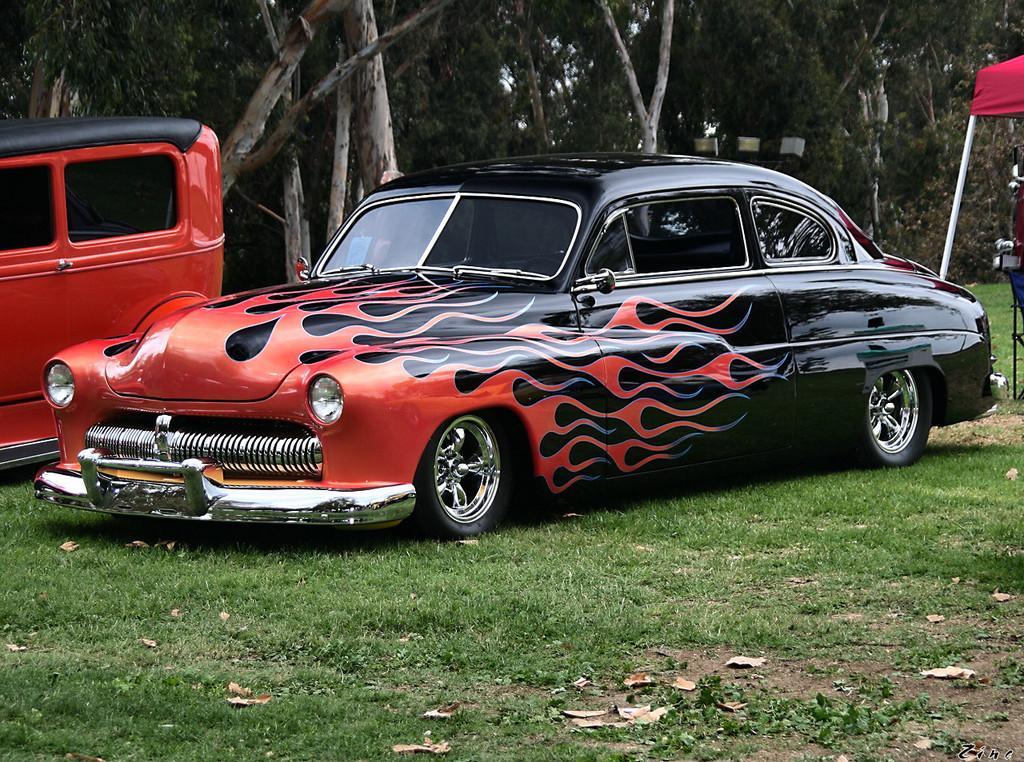Could you give a brief overview of what you see in this image? In this picture there is a sports car in the center of the image and there is a van on the left side of the image, there is a tent on the right side of the image and there are trees in the background area of the image. 